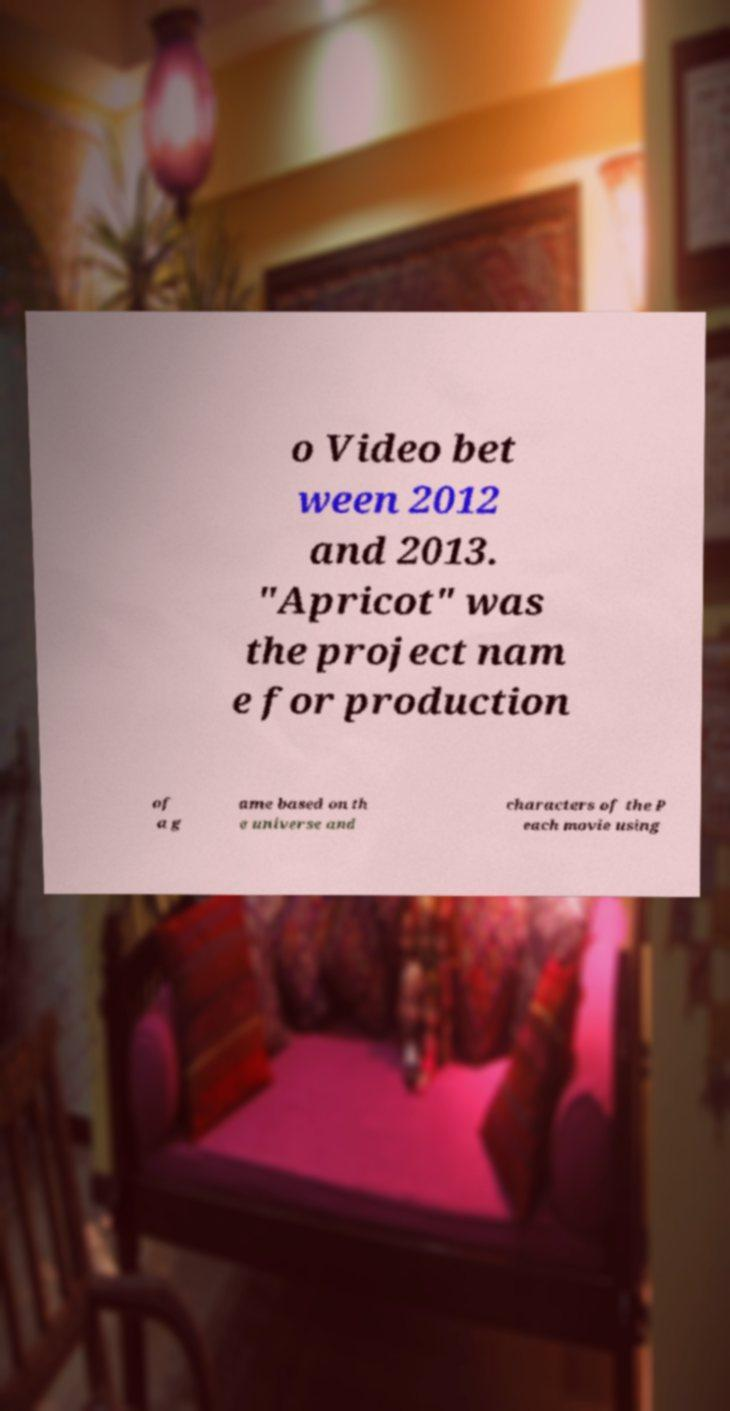For documentation purposes, I need the text within this image transcribed. Could you provide that? o Video bet ween 2012 and 2013. "Apricot" was the project nam e for production of a g ame based on th e universe and characters of the P each movie using 